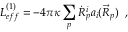<formula> <loc_0><loc_0><loc_500><loc_500>L _ { e f f } ^ { ( 1 ) } = - 4 \pi \kappa \sum _ { p } \dot { R } _ { p } ^ { i } a _ { i } ( \vec { R } _ { p } ) \, ,</formula> 